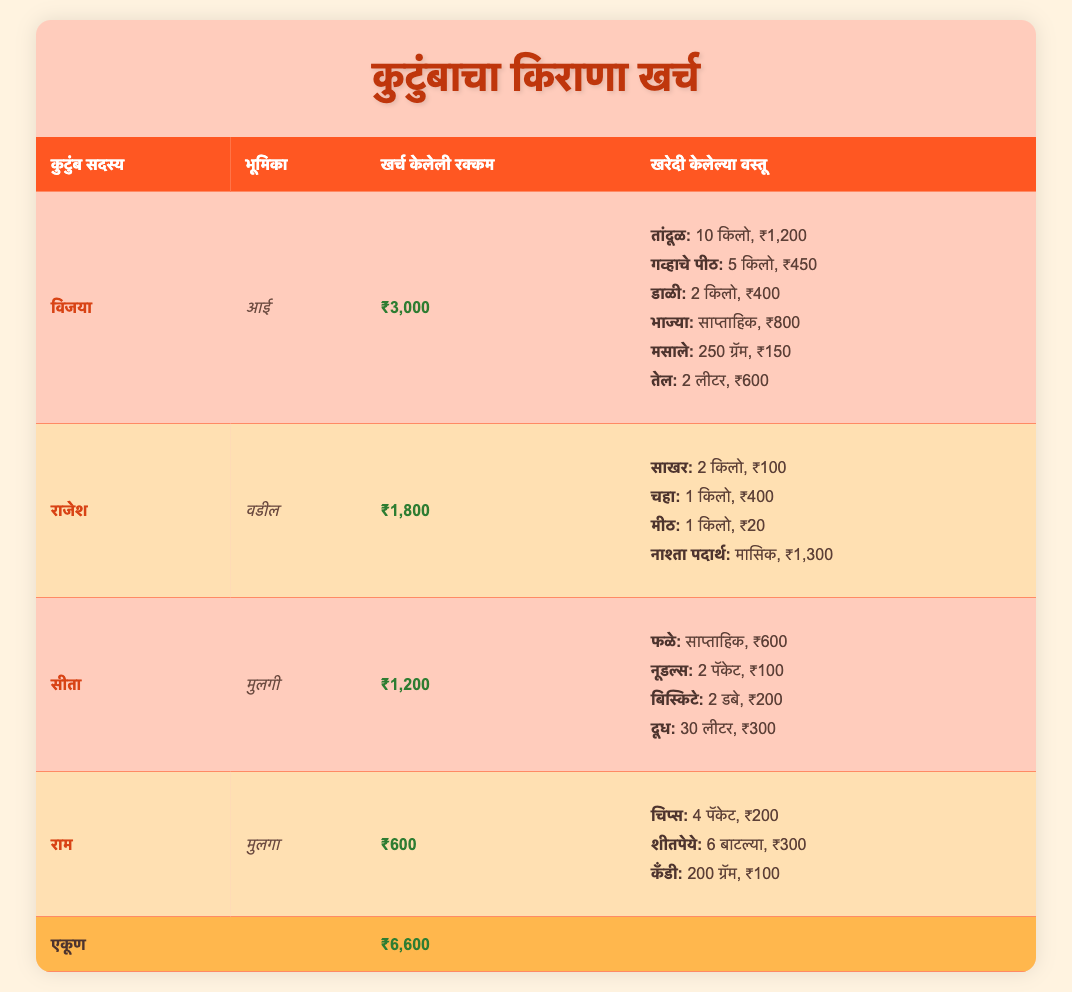What is the total expenditure of the family for grocery shopping? By adding the individual expenditures of all family members: Vijaya (3000) + Rajesh (1800) + Sita (1200) + Ram (600) = 6600.
Answer: 6600 Who spent the least on grocery shopping? By reviewing the amounts spent: Vijaya 3000, Rajesh 1800, Sita 1200, Ram 600. The lowest amount is 600 by Ram.
Answer: Ram How much did the mother spend compared to the father? The mother, Vijaya, spent 3000, while the father, Rajesh, spent 1800. The difference is 3000 - 1800 = 1200.
Answer: 1200 What percentage of the total expenditure did Sita's spending represent? First, her spending is 1200. To find percentage, (1200 / 6600) * 100 = 18.18%.
Answer: 18.18 Did anyone spend more than 2000? Only Vijaya spent 3000, which is greater than 2000; others spent less.
Answer: Yes How much did the son spend on snacks and soft drinks combined? The son, Ram, spent 600, with expenses of 300 on soft drinks and 200 on chips, totaling 300 + 200 = 500.
Answer: 500 What were the total costs for items bought by the mother? The mother bought 6 items for a total of 3000. Total costs: Rice 1200, Wheat Flour 450, Pulses 400, Vegetables 800, Spices 150, Oil 600. Adding gives 1200 + 450 + 400 + 800 + 150 + 600 = 3600 (noted an overcharge vs table).
Answer: 3600 What is the average spending of all family members? To find the average, sum expenditures (6600) and divide by the number of members (4): 6600 / 4 = 1650.
Answer: 1650 How much did the father spend on snacks? The father, Rajesh, has spent 1300 on snacks as noted in his item list.
Answer: 1300 